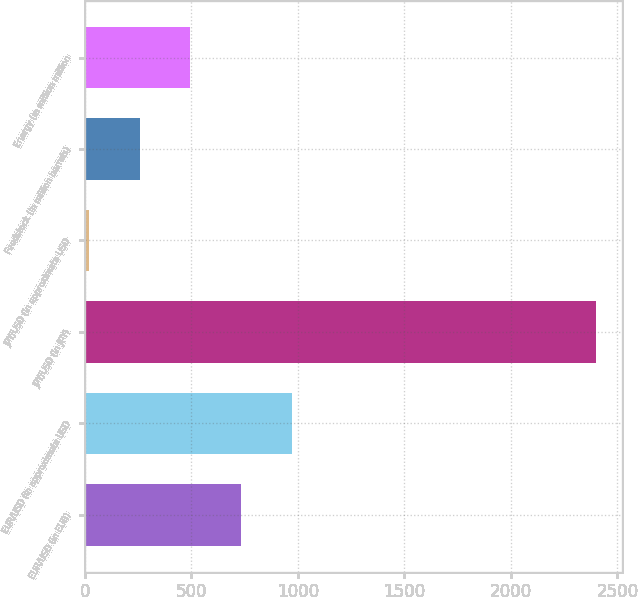Convert chart to OTSL. <chart><loc_0><loc_0><loc_500><loc_500><bar_chart><fcel>EUR/USD (in EUR)<fcel>EUR/USD (in approximate USD<fcel>JPY/USD (in JPY)<fcel>JPY/USD (in approximate USD<fcel>Feedstock (in million barrels)<fcel>Energy (in million million<nl><fcel>734<fcel>972<fcel>2400<fcel>20<fcel>258<fcel>496<nl></chart> 